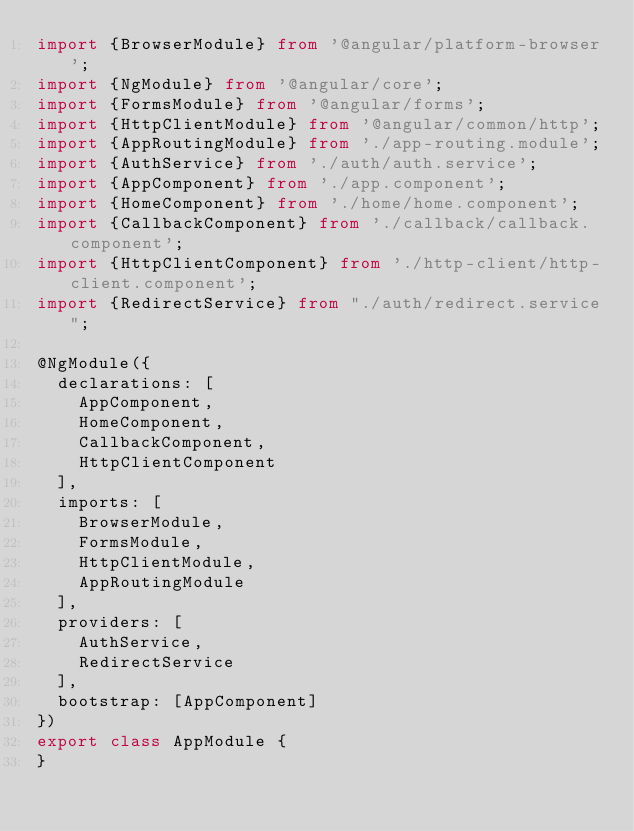<code> <loc_0><loc_0><loc_500><loc_500><_TypeScript_>import {BrowserModule} from '@angular/platform-browser';
import {NgModule} from '@angular/core';
import {FormsModule} from '@angular/forms';
import {HttpClientModule} from '@angular/common/http';
import {AppRoutingModule} from './app-routing.module';
import {AuthService} from './auth/auth.service';
import {AppComponent} from './app.component';
import {HomeComponent} from './home/home.component';
import {CallbackComponent} from './callback/callback.component';
import {HttpClientComponent} from './http-client/http-client.component';
import {RedirectService} from "./auth/redirect.service";

@NgModule({
  declarations: [
    AppComponent,
    HomeComponent,
    CallbackComponent,
    HttpClientComponent
  ],
  imports: [
    BrowserModule,
    FormsModule,
    HttpClientModule,
    AppRoutingModule
  ],
  providers: [
    AuthService,
    RedirectService
  ],
  bootstrap: [AppComponent]
})
export class AppModule {
}
</code> 